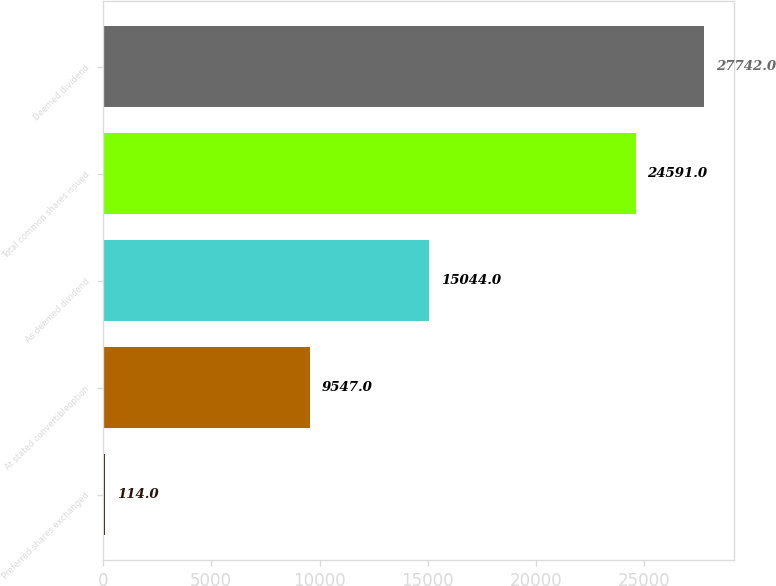Convert chart to OTSL. <chart><loc_0><loc_0><loc_500><loc_500><bar_chart><fcel>Preferred shares exchanged<fcel>At stated convertibleoption<fcel>As deemed dividend<fcel>Total common shares issued<fcel>Deemed dividend<nl><fcel>114<fcel>9547<fcel>15044<fcel>24591<fcel>27742<nl></chart> 